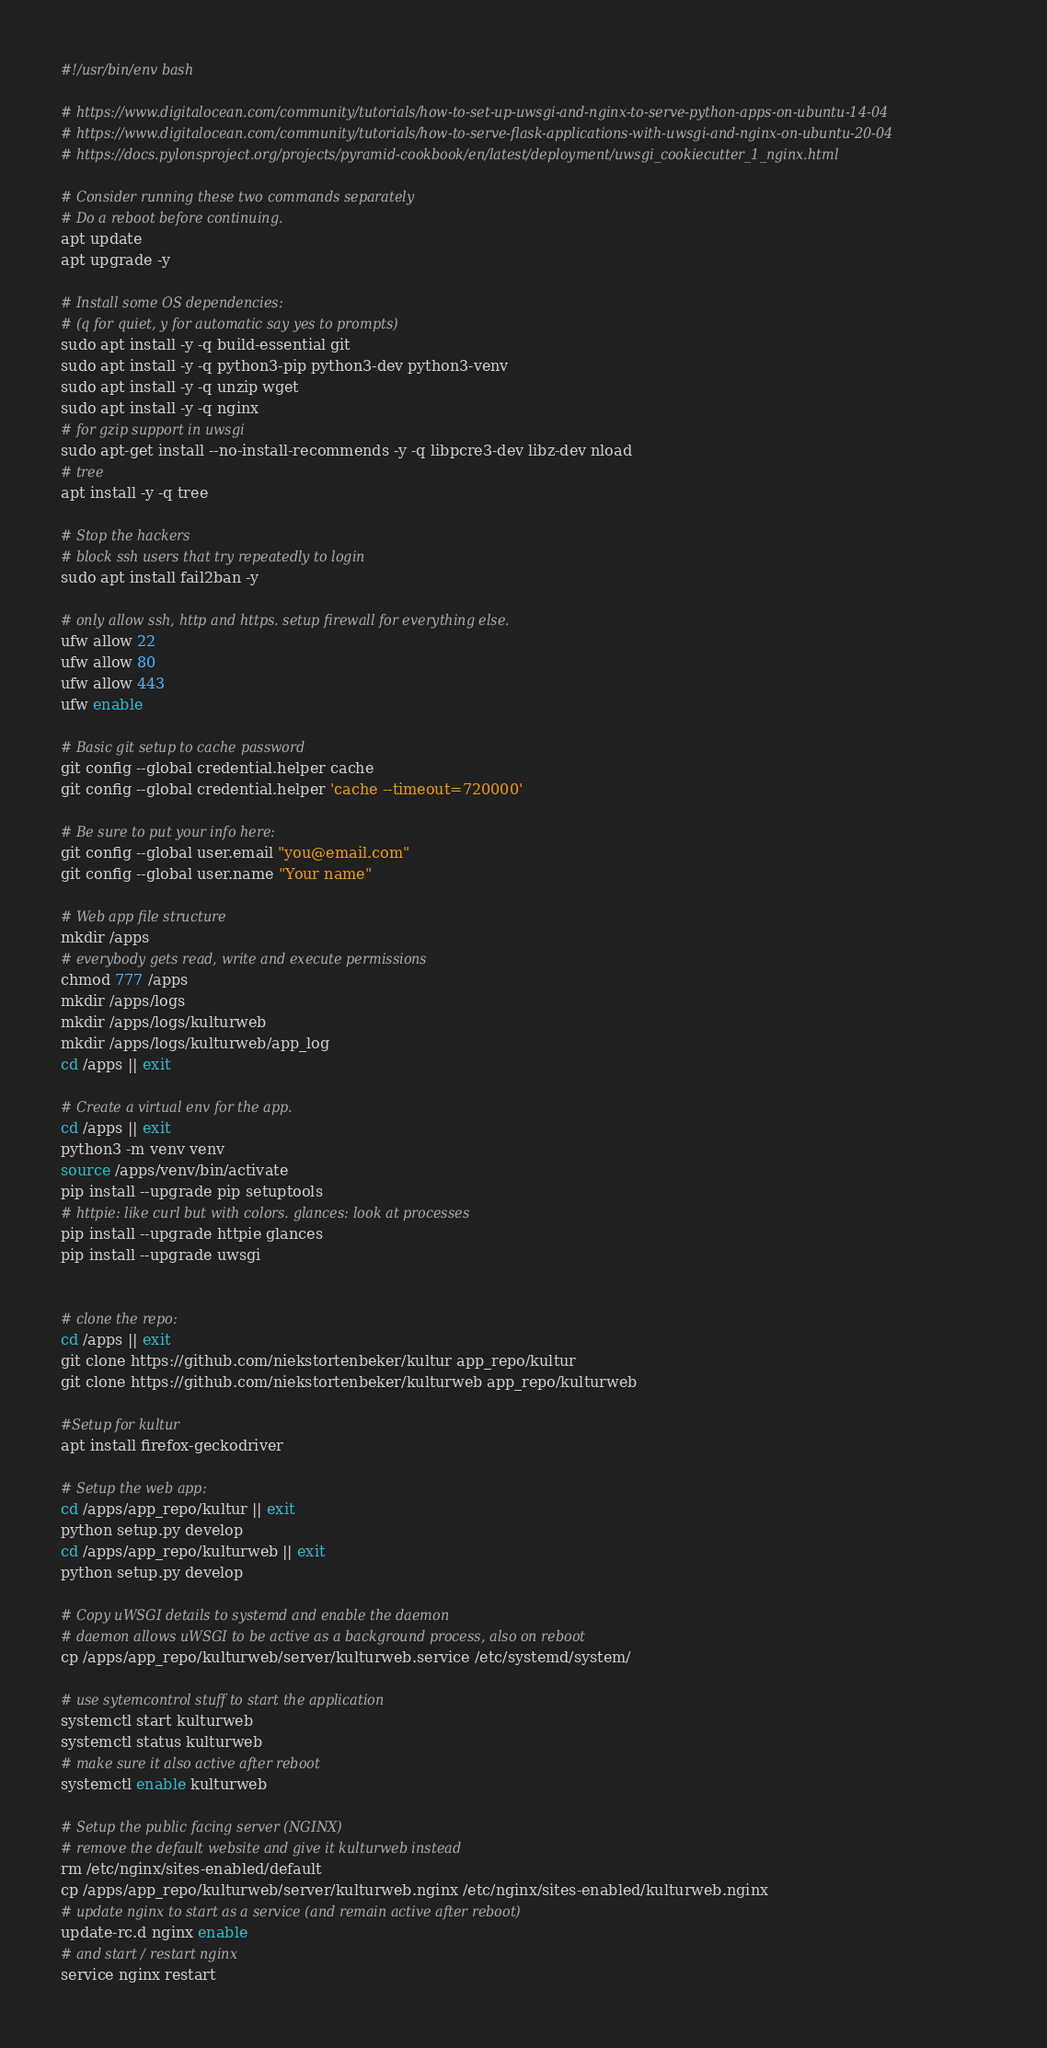<code> <loc_0><loc_0><loc_500><loc_500><_Bash_>#!/usr/bin/env bash

# https://www.digitalocean.com/community/tutorials/how-to-set-up-uwsgi-and-nginx-to-serve-python-apps-on-ubuntu-14-04
# https://www.digitalocean.com/community/tutorials/how-to-serve-flask-applications-with-uwsgi-and-nginx-on-ubuntu-20-04
# https://docs.pylonsproject.org/projects/pyramid-cookbook/en/latest/deployment/uwsgi_cookiecutter_1_nginx.html

# Consider running these two commands separately
# Do a reboot before continuing.
apt update
apt upgrade -y

# Install some OS dependencies:
# (q for quiet, y for automatic say yes to prompts)
sudo apt install -y -q build-essential git
sudo apt install -y -q python3-pip python3-dev python3-venv
sudo apt install -y -q unzip wget
sudo apt install -y -q nginx
# for gzip support in uwsgi
sudo apt-get install --no-install-recommends -y -q libpcre3-dev libz-dev nload
# tree
apt install -y -q tree

# Stop the hackers
# block ssh users that try repeatedly to login
sudo apt install fail2ban -y

# only allow ssh, http and https. setup firewall for everything else.
ufw allow 22
ufw allow 80
ufw allow 443
ufw enable

# Basic git setup to cache password
git config --global credential.helper cache
git config --global credential.helper 'cache --timeout=720000'

# Be sure to put your info here:
git config --global user.email "you@email.com"
git config --global user.name "Your name"

# Web app file structure
mkdir /apps
# everybody gets read, write and execute permissions
chmod 777 /apps
mkdir /apps/logs
mkdir /apps/logs/kulturweb
mkdir /apps/logs/kulturweb/app_log
cd /apps || exit

# Create a virtual env for the app.
cd /apps || exit
python3 -m venv venv
source /apps/venv/bin/activate
pip install --upgrade pip setuptools
# httpie: like curl but with colors. glances: look at processes
pip install --upgrade httpie glances
pip install --upgrade uwsgi


# clone the repo:
cd /apps || exit
git clone https://github.com/niekstortenbeker/kultur app_repo/kultur
git clone https://github.com/niekstortenbeker/kulturweb app_repo/kulturweb

#Setup for kultur
apt install firefox-geckodriver

# Setup the web app:
cd /apps/app_repo/kultur || exit
python setup.py develop
cd /apps/app_repo/kulturweb || exit
python setup.py develop

# Copy uWSGI details to systemd and enable the daemon
# daemon allows uWSGI to be active as a background process, also on reboot
cp /apps/app_repo/kulturweb/server/kulturweb.service /etc/systemd/system/

# use sytemcontrol stuff to start the application
systemctl start kulturweb
systemctl status kulturweb
# make sure it also active after reboot
systemctl enable kulturweb

# Setup the public facing server (NGINX)
# remove the default website and give it kulturweb instead
rm /etc/nginx/sites-enabled/default
cp /apps/app_repo/kulturweb/server/kulturweb.nginx /etc/nginx/sites-enabled/kulturweb.nginx
# update nginx to start as a service (and remain active after reboot)
update-rc.d nginx enable
# and start / restart nginx
service nginx restart
</code> 